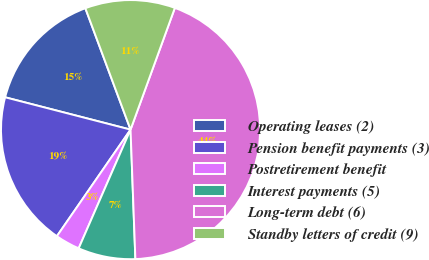Convert chart to OTSL. <chart><loc_0><loc_0><loc_500><loc_500><pie_chart><fcel>Operating leases (2)<fcel>Pension benefit payments (3)<fcel>Postretirement benefit<fcel>Interest payments (5)<fcel>Long-term debt (6)<fcel>Standby letters of credit (9)<nl><fcel>15.31%<fcel>19.39%<fcel>3.07%<fcel>7.15%<fcel>43.85%<fcel>11.23%<nl></chart> 